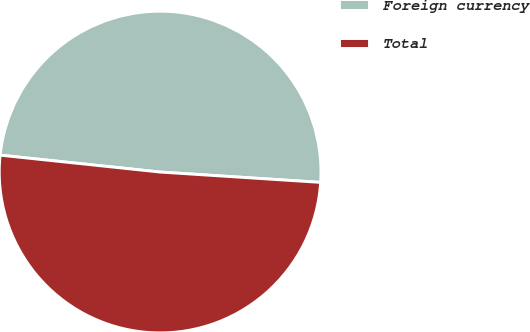Convert chart to OTSL. <chart><loc_0><loc_0><loc_500><loc_500><pie_chart><fcel>Foreign currency<fcel>Total<nl><fcel>49.35%<fcel>50.65%<nl></chart> 